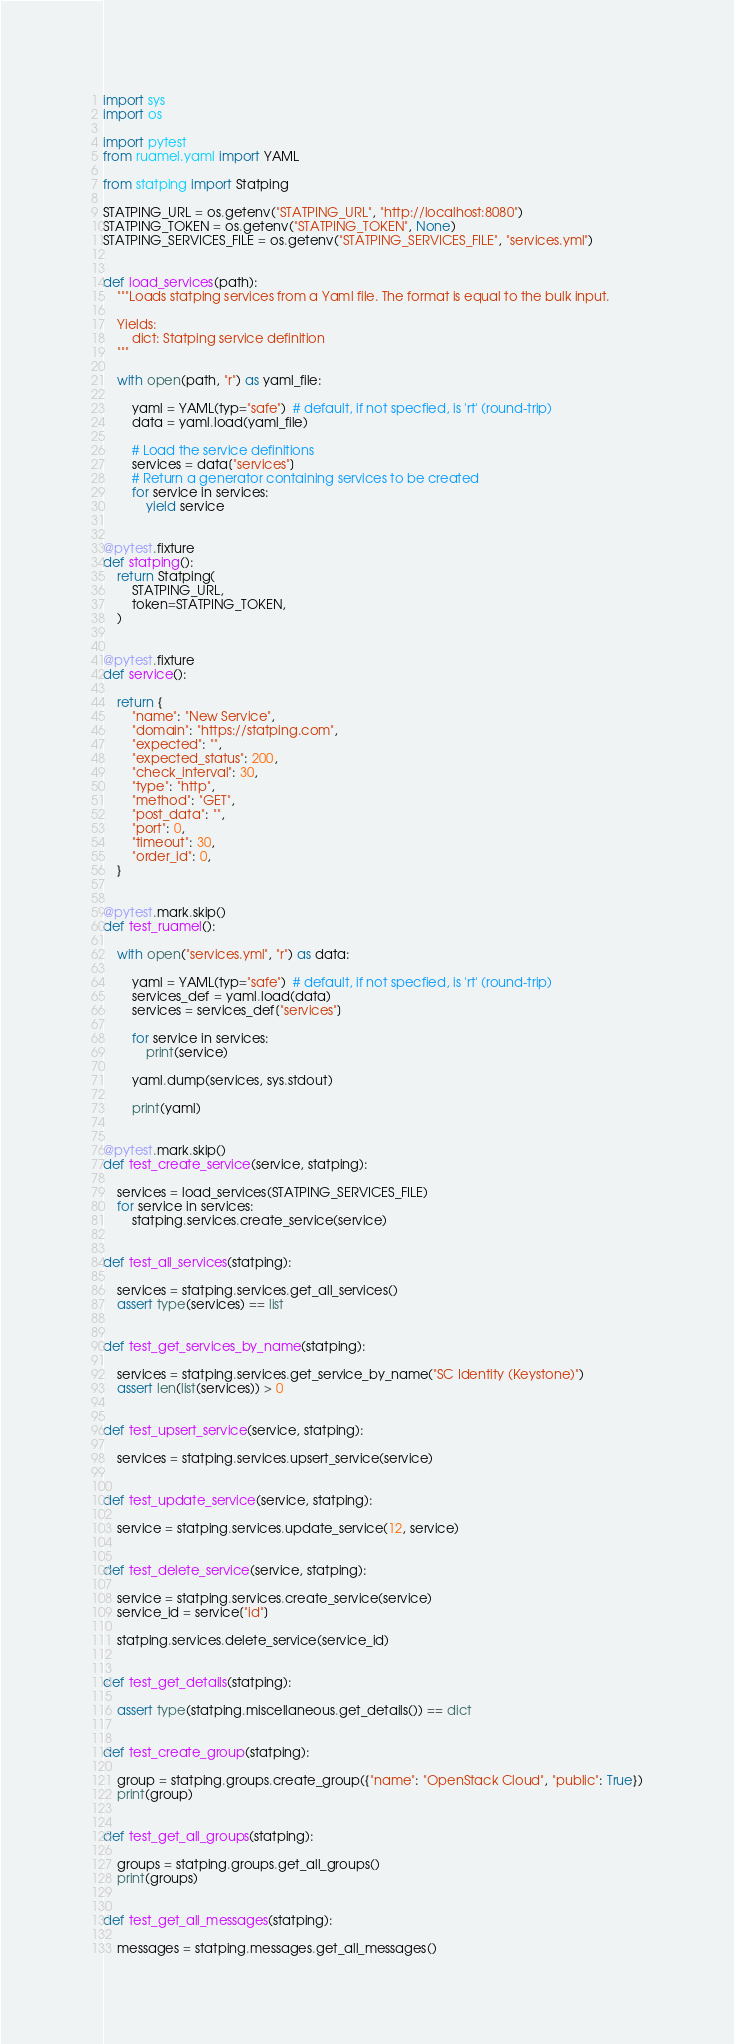<code> <loc_0><loc_0><loc_500><loc_500><_Python_>import sys
import os

import pytest
from ruamel.yaml import YAML

from statping import Statping

STATPING_URL = os.getenv("STATPING_URL", "http://localhost:8080")
STATPING_TOKEN = os.getenv("STATPING_TOKEN", None)
STATPING_SERVICES_FILE = os.getenv("STATPING_SERVICES_FILE", "services.yml")


def load_services(path):
    """Loads statping services from a Yaml file. The format is equal to the bulk input.

    Yields:
        dict: Statping service definition
    """

    with open(path, "r") as yaml_file:

        yaml = YAML(typ="safe")  # default, if not specfied, is 'rt' (round-trip)
        data = yaml.load(yaml_file)

        # Load the service definitions
        services = data["services"]
        # Return a generator containing services to be created
        for service in services:
            yield service


@pytest.fixture
def statping():
    return Statping(
        STATPING_URL,
        token=STATPING_TOKEN,
    )


@pytest.fixture
def service():

    return {
        "name": "New Service",
        "domain": "https://statping.com",
        "expected": "",
        "expected_status": 200,
        "check_interval": 30,
        "type": "http",
        "method": "GET",
        "post_data": "",
        "port": 0,
        "timeout": 30,
        "order_id": 0,
    }


@pytest.mark.skip()
def test_ruamel():

    with open("services.yml", "r") as data:

        yaml = YAML(typ="safe")  # default, if not specfied, is 'rt' (round-trip)
        services_def = yaml.load(data)
        services = services_def["services"]

        for service in services:
            print(service)

        yaml.dump(services, sys.stdout)

        print(yaml)


@pytest.mark.skip()
def test_create_service(service, statping):

    services = load_services(STATPING_SERVICES_FILE)
    for service in services:
        statping.services.create_service(service)


def test_all_services(statping):

    services = statping.services.get_all_services()
    assert type(services) == list


def test_get_services_by_name(statping):

    services = statping.services.get_service_by_name("SC Identity (Keystone)")
    assert len(list(services)) > 0


def test_upsert_service(service, statping):

    services = statping.services.upsert_service(service)


def test_update_service(service, statping):

    service = statping.services.update_service(12, service)


def test_delete_service(service, statping):

    service = statping.services.create_service(service)
    service_id = service["id"]

    statping.services.delete_service(service_id)


def test_get_details(statping):

    assert type(statping.miscellaneous.get_details()) == dict


def test_create_group(statping):

    group = statping.groups.create_group({"name": "OpenStack Cloud", "public": True})
    print(group)


def test_get_all_groups(statping):

    groups = statping.groups.get_all_groups()
    print(groups)


def test_get_all_messages(statping):

    messages = statping.messages.get_all_messages()
</code> 